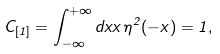<formula> <loc_0><loc_0><loc_500><loc_500>C _ { [ 1 ] } = \int _ { - \infty } ^ { + \infty } d x x \, \eta ^ { 2 } ( - x ) = 1 ,</formula> 